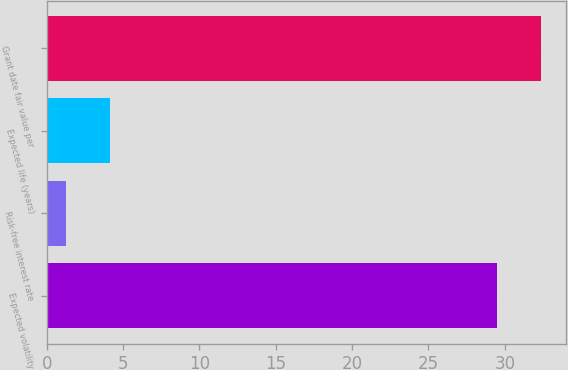Convert chart. <chart><loc_0><loc_0><loc_500><loc_500><bar_chart><fcel>Expected volatility<fcel>Risk-free interest rate<fcel>Expected life (years)<fcel>Grant date fair value per<nl><fcel>29.5<fcel>1.24<fcel>4.11<fcel>32.37<nl></chart> 